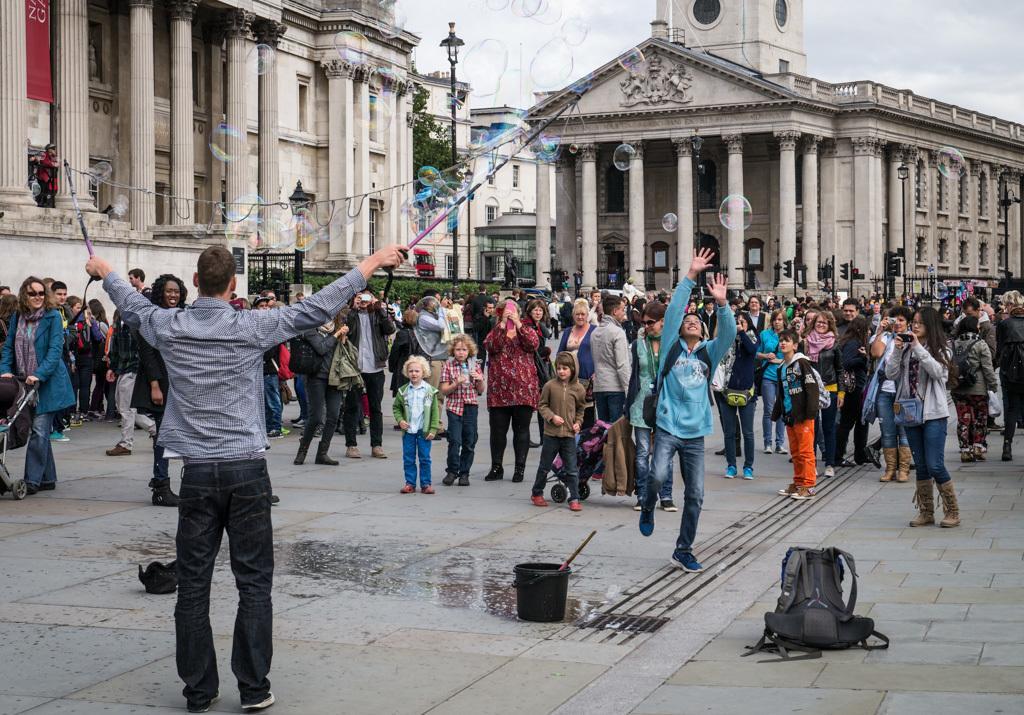Describe this image in one or two sentences. In this image we can see few buildings and in front of the building there are a group of people, some of them are clicking picture, and a man is holding an object and there is a bucket and backpack on the ground. 